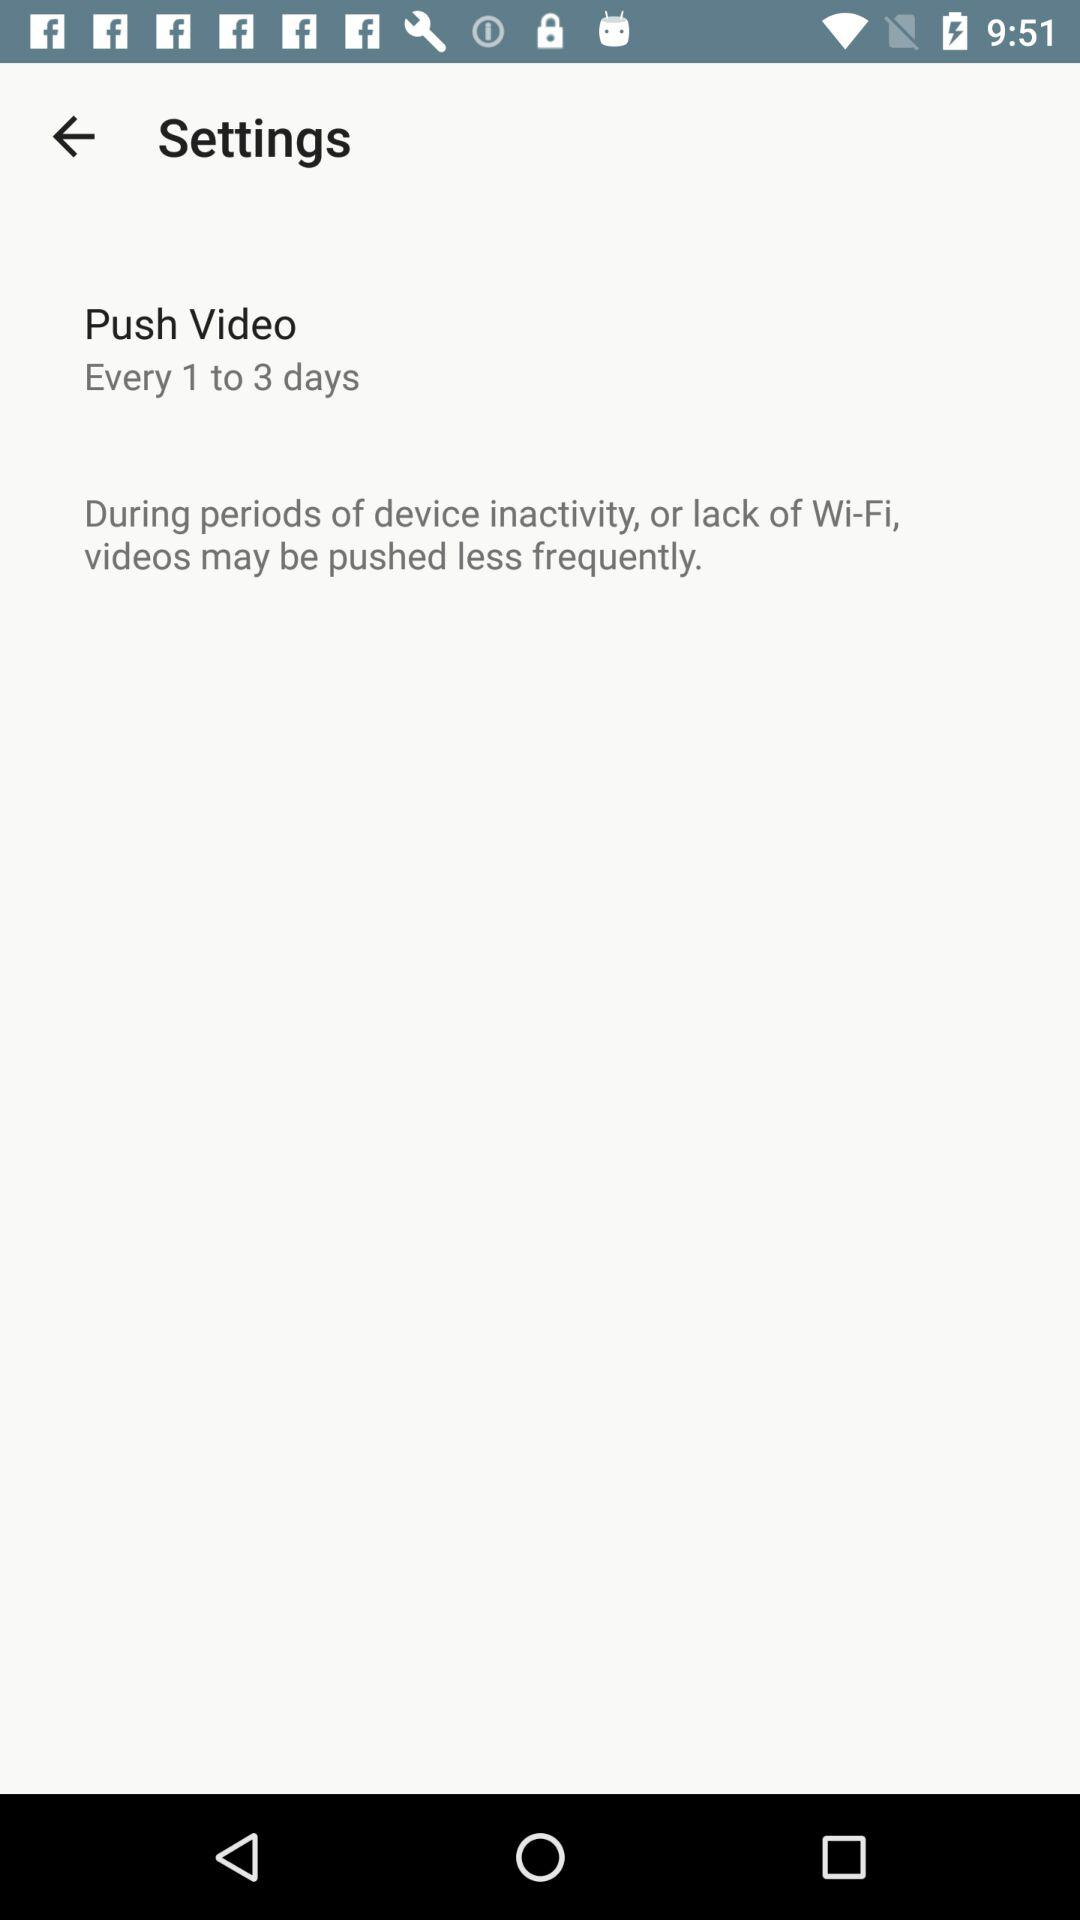How many days longer is the minimum interval between videos than the maximum interval?
Answer the question using a single word or phrase. 2 